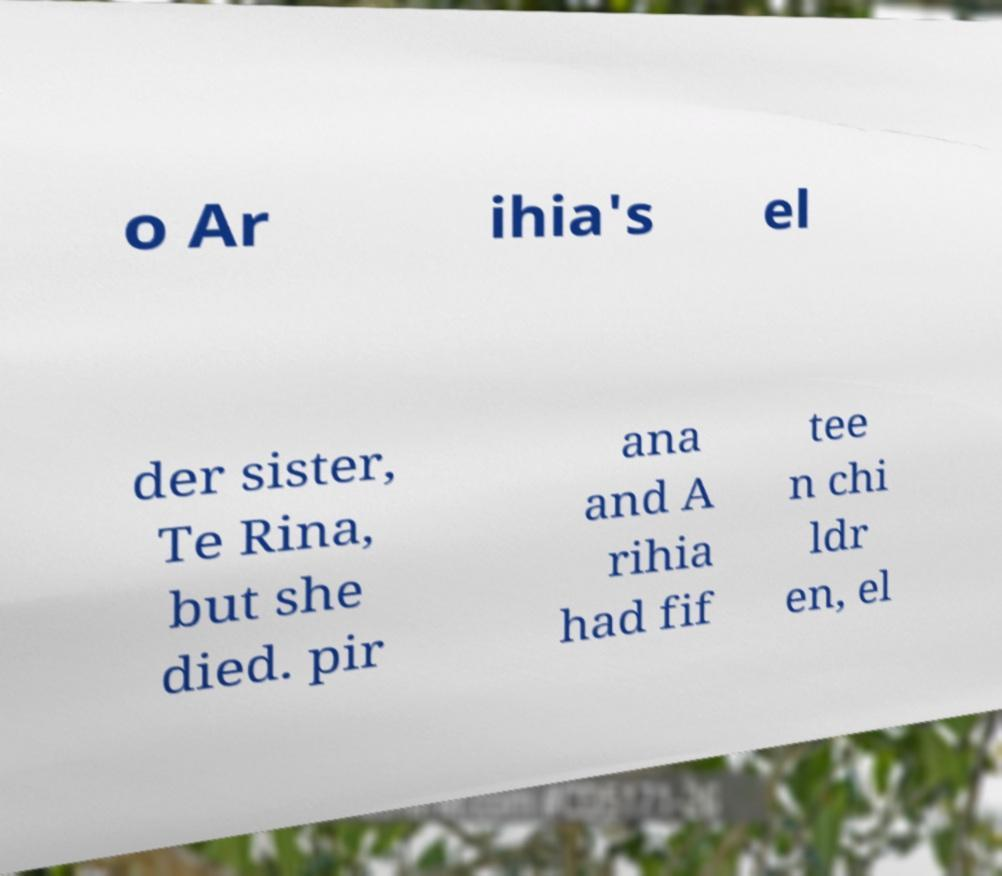Please identify and transcribe the text found in this image. o Ar ihia's el der sister, Te Rina, but she died. pir ana and A rihia had fif tee n chi ldr en, el 